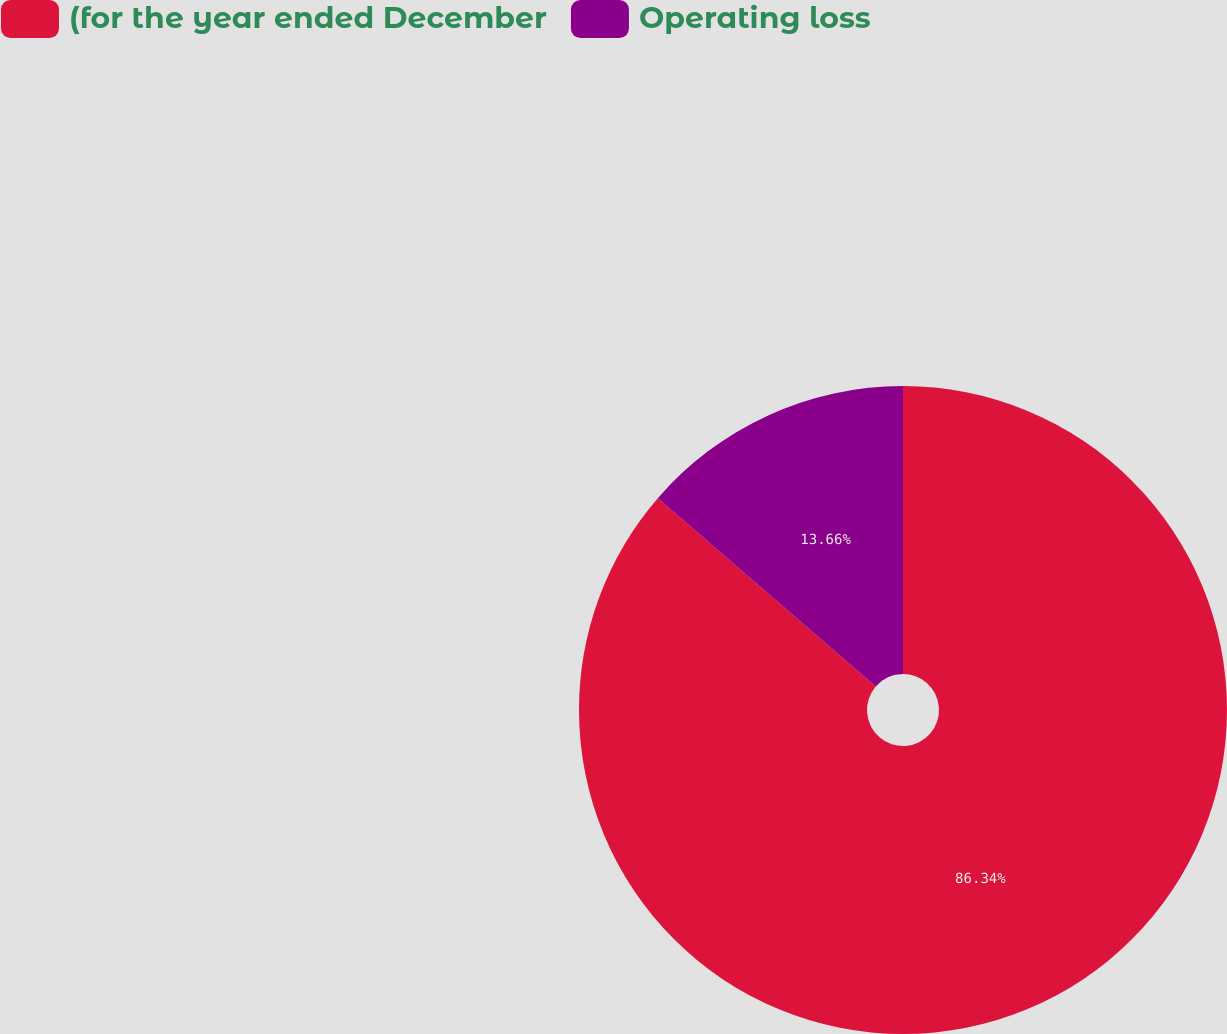Convert chart. <chart><loc_0><loc_0><loc_500><loc_500><pie_chart><fcel>(for the year ended December<fcel>Operating loss<nl><fcel>86.34%<fcel>13.66%<nl></chart> 